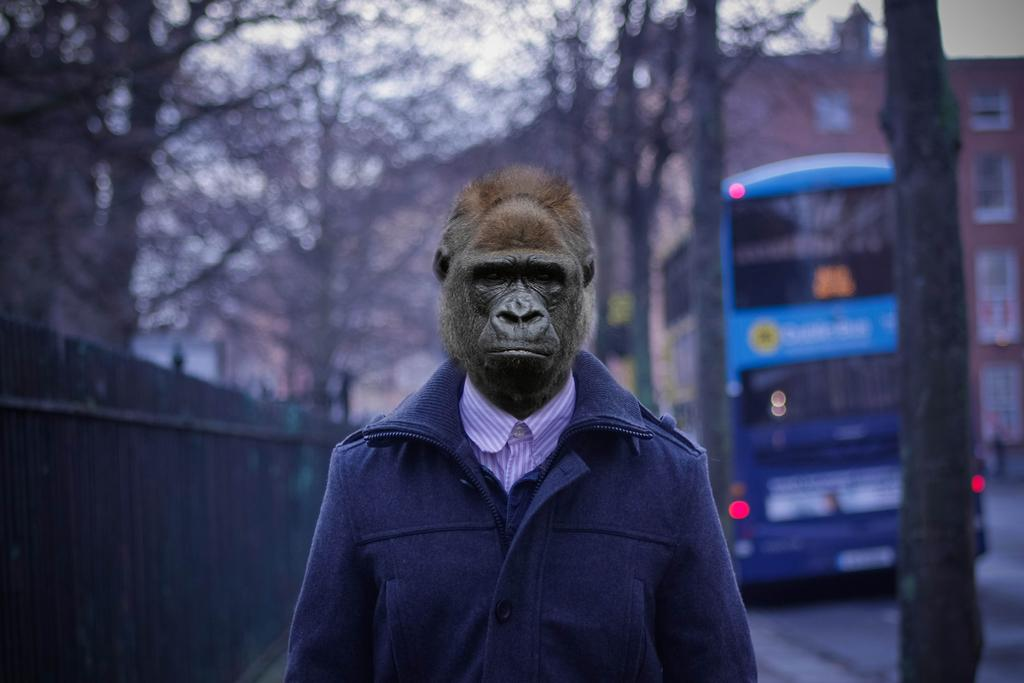What is the main subject in the center of the image? There is a chimpanzee in the center of the image. What can be seen in the background of the image? There are trees, a bus, buildings, and the sky visible in the background of the image. What type of cave can be seen in the background of the image? There is no cave present in the image; it features a chimpanzee in the center and various background elements. What type of business is being conducted in the image? The image does not depict any business activities; it primarily focuses on the chimpanzee and the background elements. 